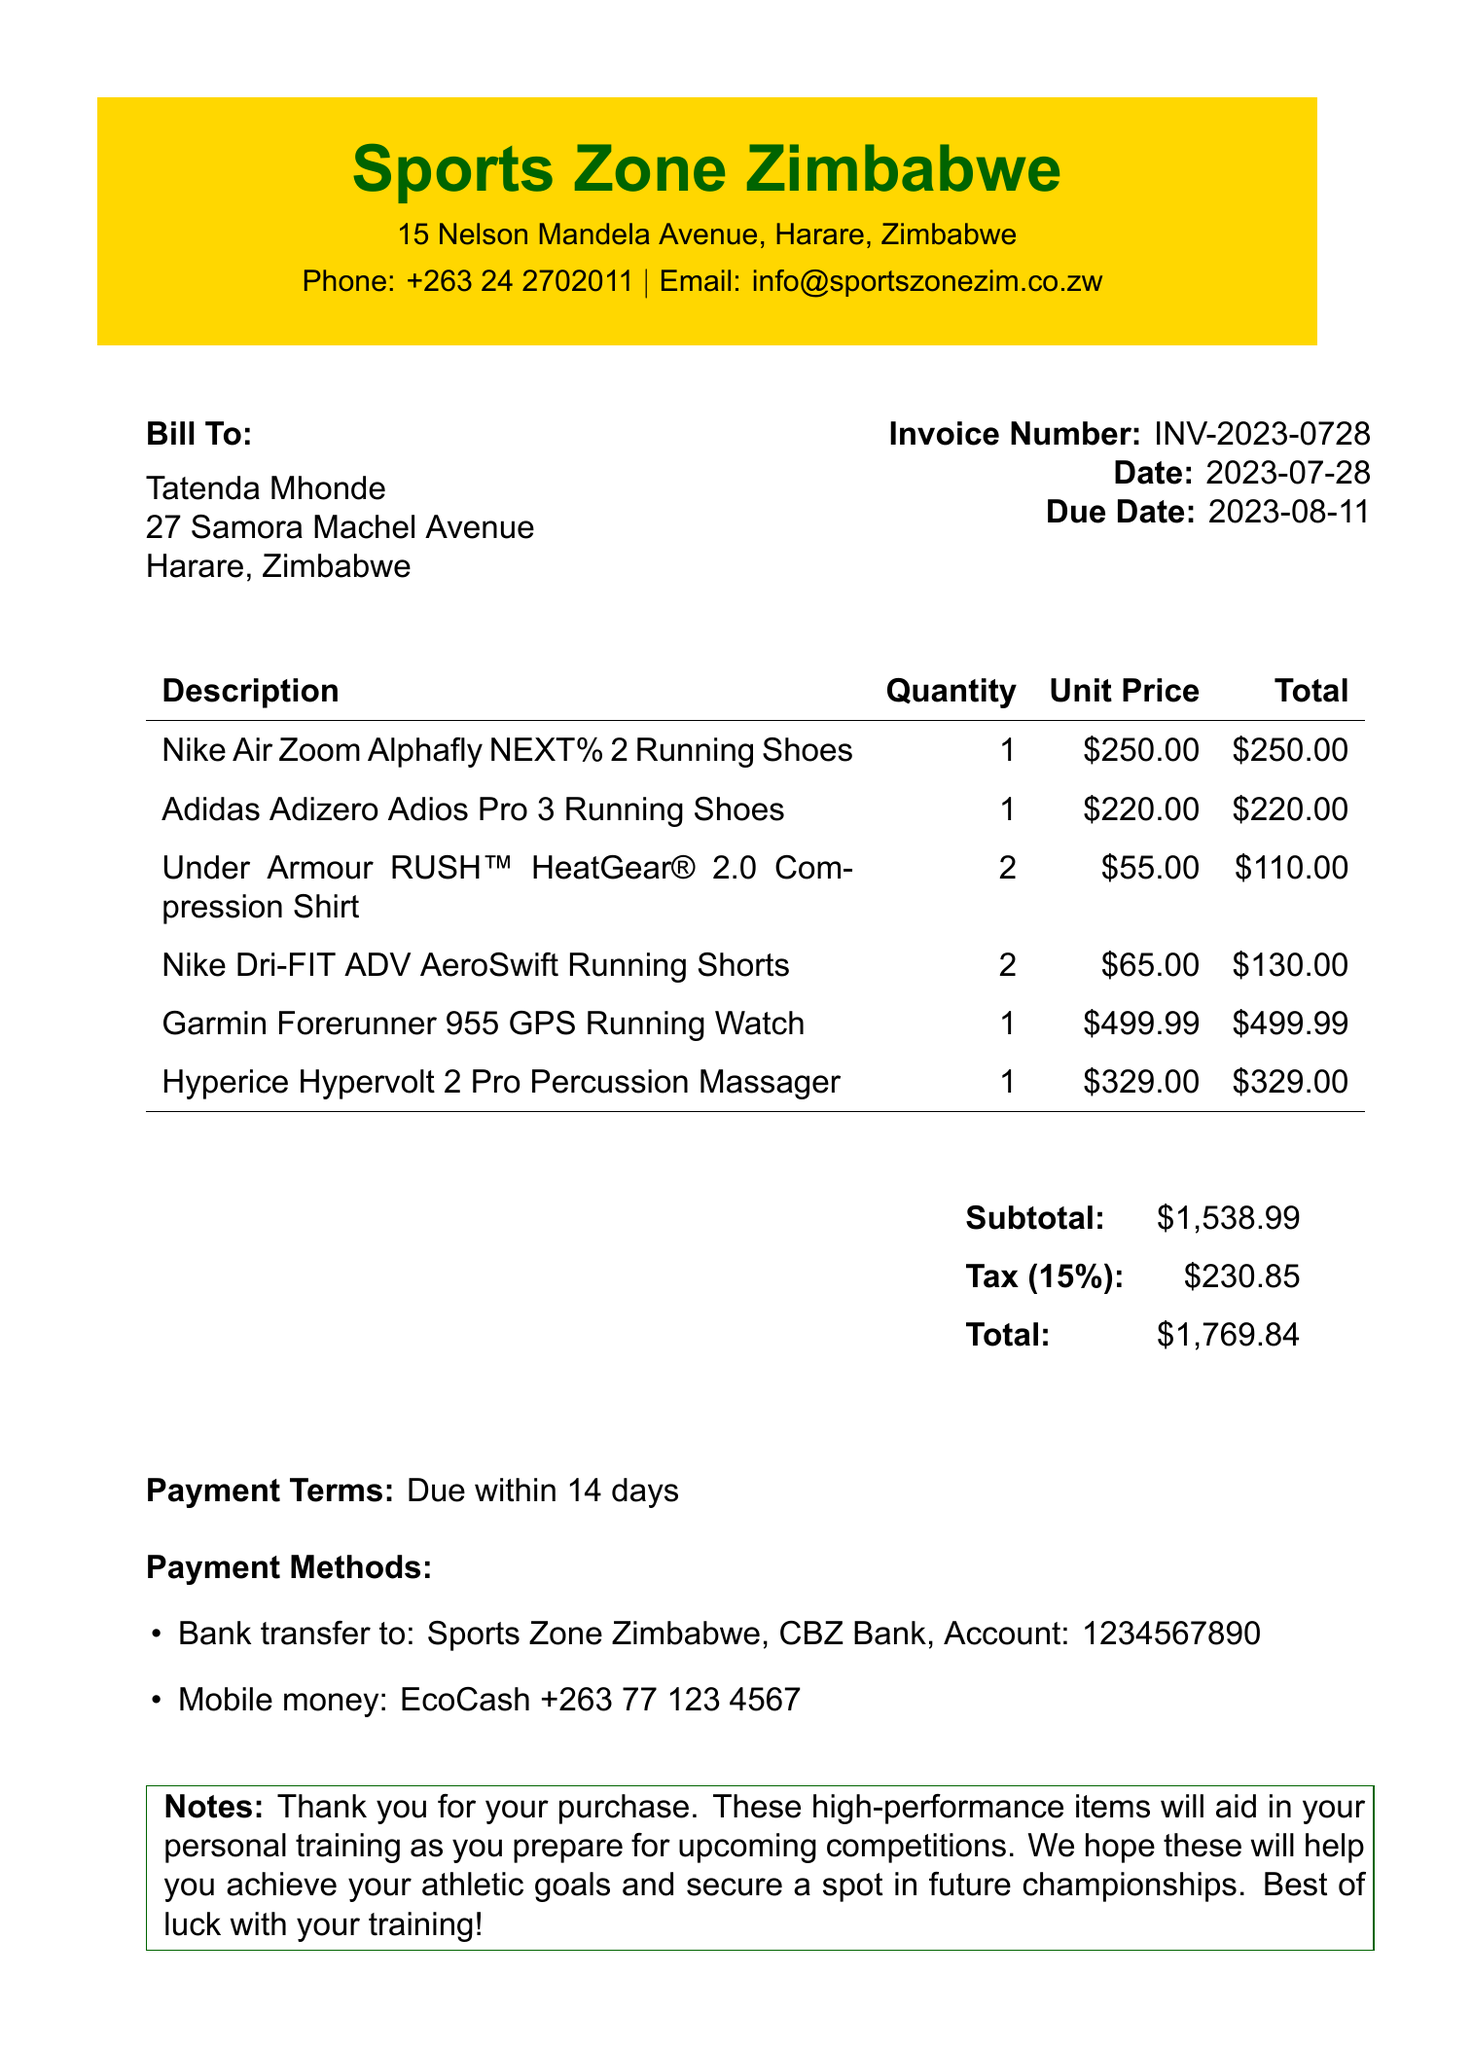What is the invoice number? The invoice number is clearly stated in the document as the identifier for this transaction.
Answer: INV-2023-0728 What is the due date for the invoice? The due date is the last date by which payment should be made, as specified in the document.
Answer: 2023-08-11 What is the total amount due? The total amount due is calculated as the sum of subtotal and tax according to the invoice.
Answer: $1769.84 Who is the seller? The seller's information is provided in the document, detailing the business name and location.
Answer: Sports Zone Zimbabwe How many Under Armour compression shirts were purchased? The quantity of a specific item can be found in the line item details within the invoice.
Answer: 2 What is the tax rate applied to the items? The tax rate is specified in the invoice, indicating the percentage charged on the subtotal.
Answer: 15% Which payment method is mentioned in the invoice? The document provides specific payment methods that can be used to settle the invoice.
Answer: Bank transfer and Mobile money What is the subtotal before tax? The subtotal is clearly listed in the document as part of the financial summary.
Answer: $1538.99 What is included in the notes section? The notes section contains additional comments from the seller to the purchaser regarding the purchase.
Answer: Thank you for your purchase 